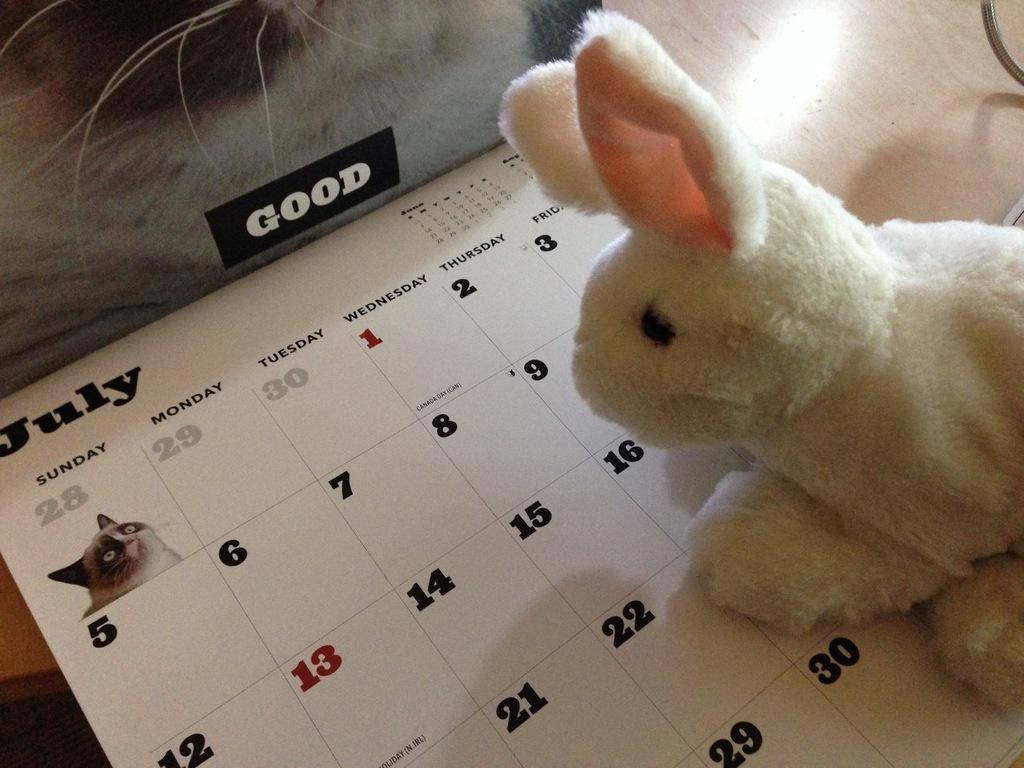What type of toy is in the picture? There is a soft toy in the picture. What other object can be seen in the picture? There is a calendar in the picture. Can you describe any other objects in the picture? There are other unspecified objects in the picture. What role does the actor play in the picture? There is no actor present in the picture; it features a soft toy and a calendar. Is the wren visible in the picture? There is no wren present in the picture. 